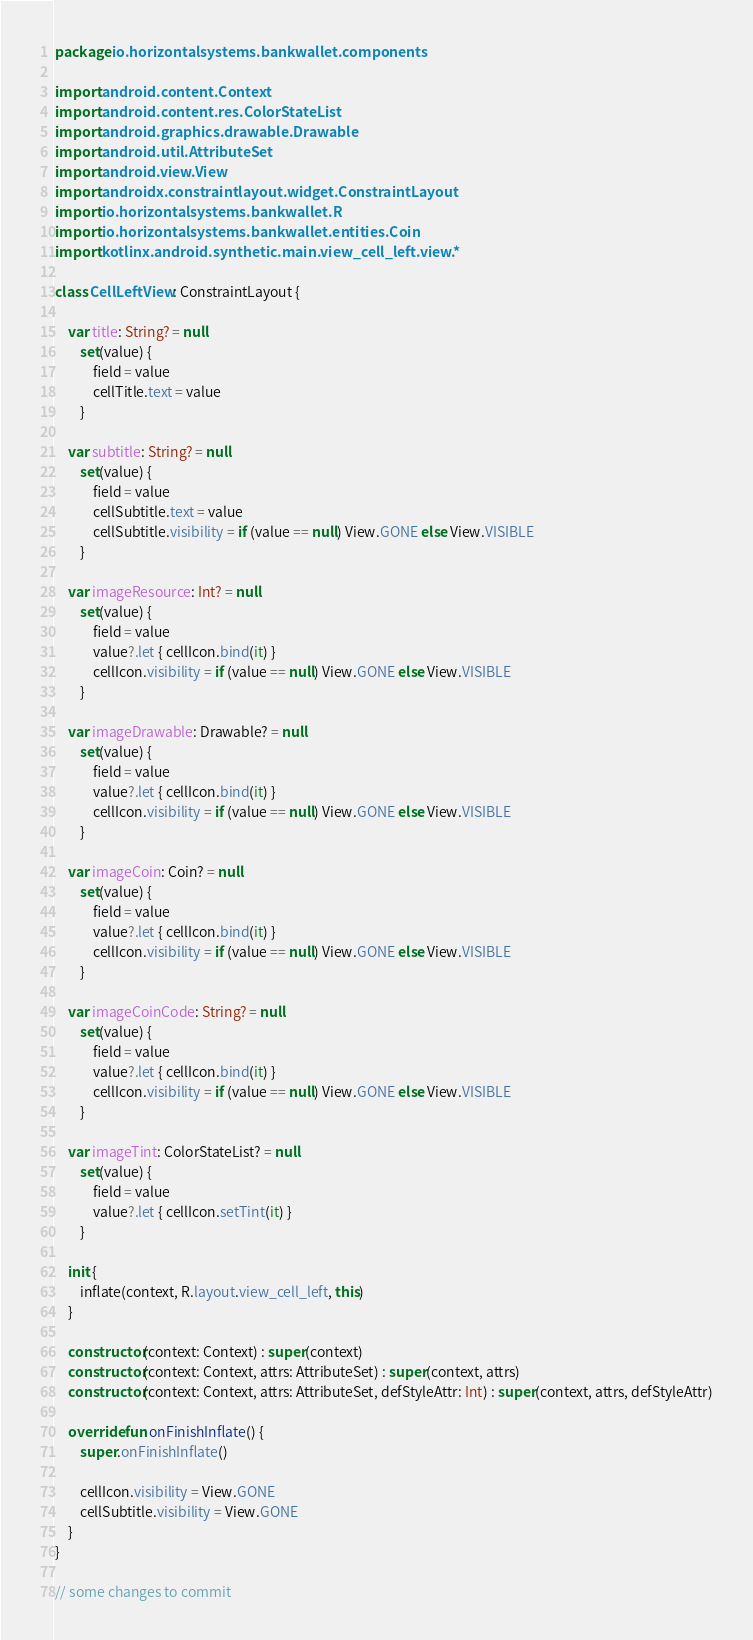<code> <loc_0><loc_0><loc_500><loc_500><_Kotlin_>package io.horizontalsystems.bankwallet.components

import android.content.Context
import android.content.res.ColorStateList
import android.graphics.drawable.Drawable
import android.util.AttributeSet
import android.view.View
import androidx.constraintlayout.widget.ConstraintLayout
import io.horizontalsystems.bankwallet.R
import io.horizontalsystems.bankwallet.entities.Coin
import kotlinx.android.synthetic.main.view_cell_left.view.*

class CellLeftView : ConstraintLayout {

    var title: String? = null
        set(value) {
            field = value
            cellTitle.text = value
        }

    var subtitle: String? = null
        set(value) {
            field = value
            cellSubtitle.text = value
            cellSubtitle.visibility = if (value == null) View.GONE else View.VISIBLE
        }

    var imageResource: Int? = null
        set(value) {
            field = value
            value?.let { cellIcon.bind(it) }
            cellIcon.visibility = if (value == null) View.GONE else View.VISIBLE
        }

    var imageDrawable: Drawable? = null
        set(value) {
            field = value
            value?.let { cellIcon.bind(it) }
            cellIcon.visibility = if (value == null) View.GONE else View.VISIBLE
        }

    var imageCoin: Coin? = null
        set(value) {
            field = value
            value?.let { cellIcon.bind(it) }
            cellIcon.visibility = if (value == null) View.GONE else View.VISIBLE
        }

    var imageCoinCode: String? = null
        set(value) {
            field = value
            value?.let { cellIcon.bind(it) }
            cellIcon.visibility = if (value == null) View.GONE else View.VISIBLE
        }

    var imageTint: ColorStateList? = null
        set(value) {
            field = value
            value?.let { cellIcon.setTint(it) }
        }

    init {
        inflate(context, R.layout.view_cell_left, this)
    }

    constructor(context: Context) : super(context)
    constructor(context: Context, attrs: AttributeSet) : super(context, attrs)
    constructor(context: Context, attrs: AttributeSet, defStyleAttr: Int) : super(context, attrs, defStyleAttr)

    override fun onFinishInflate() {
        super.onFinishInflate()

        cellIcon.visibility = View.GONE
        cellSubtitle.visibility = View.GONE
    }
}

// some changes to commit</code> 